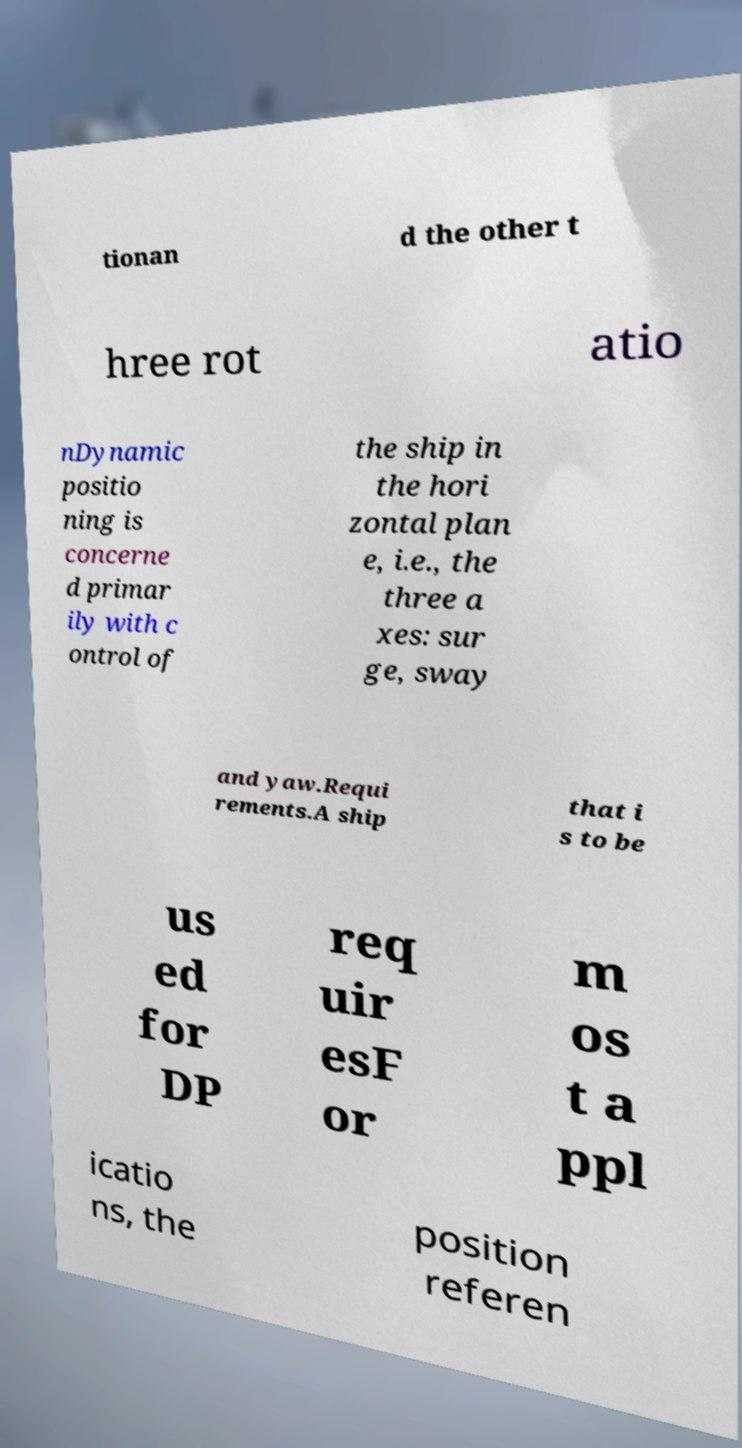Could you assist in decoding the text presented in this image and type it out clearly? tionan d the other t hree rot atio nDynamic positio ning is concerne d primar ily with c ontrol of the ship in the hori zontal plan e, i.e., the three a xes: sur ge, sway and yaw.Requi rements.A ship that i s to be us ed for DP req uir esF or m os t a ppl icatio ns, the position referen 